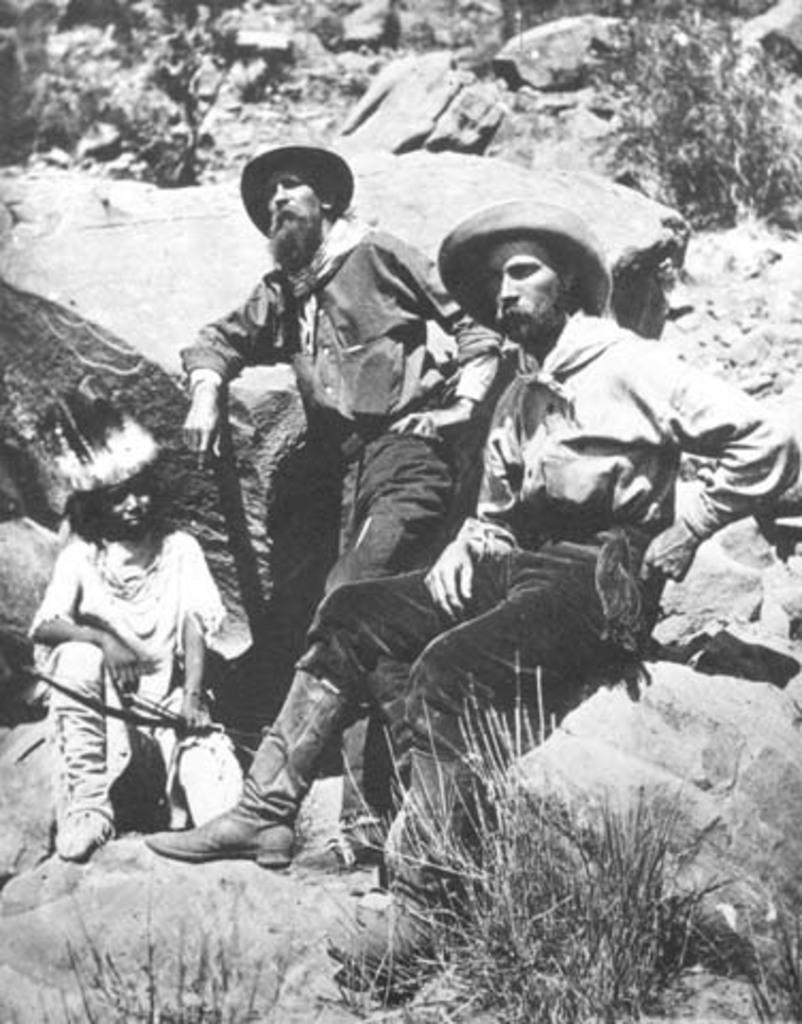What is the color scheme of the image? The image is in black and white. How many people are in the image? There are three persons in the image. What are the persons sitting on? The persons are sitting on rocks. What type of vegetation is visible in the image? There is grass visible in the image. What type of suit is the person on the left wearing in the image? There is no suit visible in the image, as it is in black and white and does not show any clothing details. 